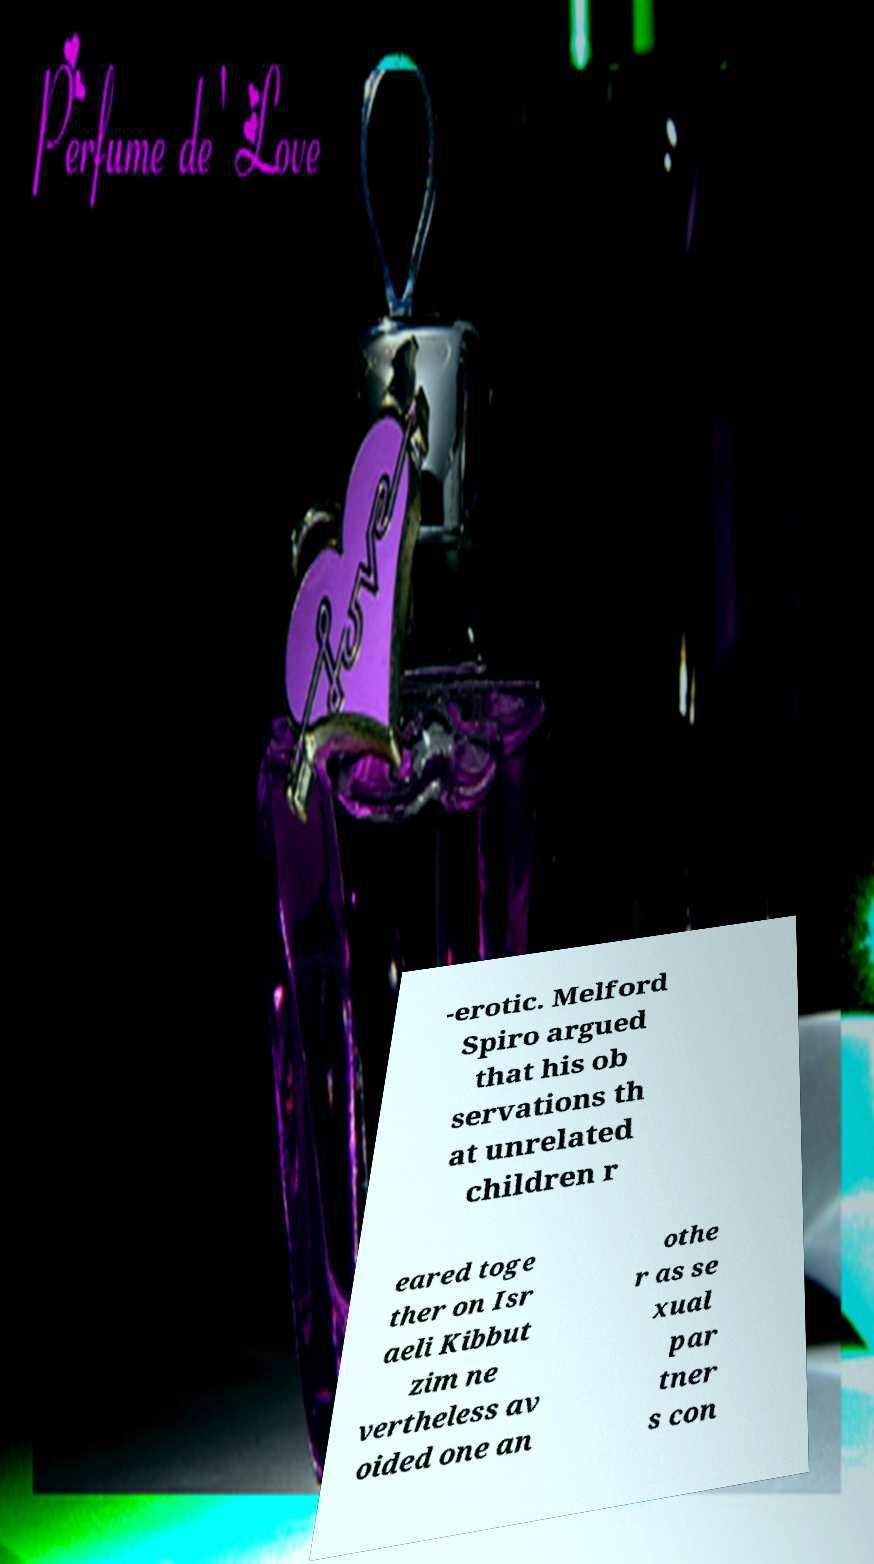I need the written content from this picture converted into text. Can you do that? -erotic. Melford Spiro argued that his ob servations th at unrelated children r eared toge ther on Isr aeli Kibbut zim ne vertheless av oided one an othe r as se xual par tner s con 